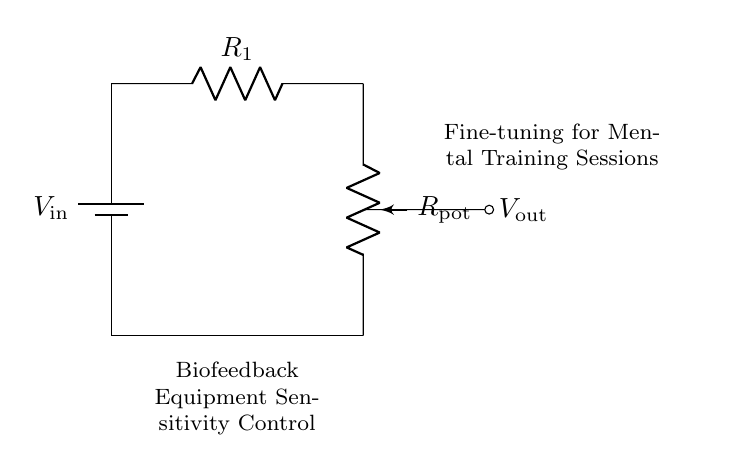What does the potentiometer represent in this circuit? The potentiometer represents a variable resistor that allows for adjustment of the resistance and thus fine-tuning the sensitivity of the biofeedback equipment.
Answer: variable resistor What is the role of the battery in this circuit? The battery provides the input voltage needed for the circuit to function, establishing a potential difference across the components.
Answer: input voltage How many resistive elements are in this circuit? There are two resistive elements: one fixed resistor and one variable resistor (the potentiometer).
Answer: two What is the function of the output voltage in this circuit setup? The output voltage is taken across the potentiometer and represents the adjusted level of sensitivity for the biofeedback equipment during mental training sessions.
Answer: adjusted sensitivity level What will happen to the output voltage if the resistance of the potentiometer is increased? Increasing the resistance of the potentiometer will result in a higher output voltage as it alters the voltage division across the resistors.
Answer: higher output voltage Calculate the total resistance if the potentiometer is set to maximum resistance of 10 kilo-ohms and R1 is 5 kilo-ohms. The total resistance in series is simply the sum of the two resistors. Therefore, total resistance equals 10 kilo-ohms plus 5 kilo-ohms, which equals 15 kilo-ohms.
Answer: 15 kilo-ohms What type of circuit is represented here? This circuit is a voltage divider, specifically utilizing a potentiometer to adjust the output voltage based on the potential difference created by the input voltage.
Answer: voltage divider 